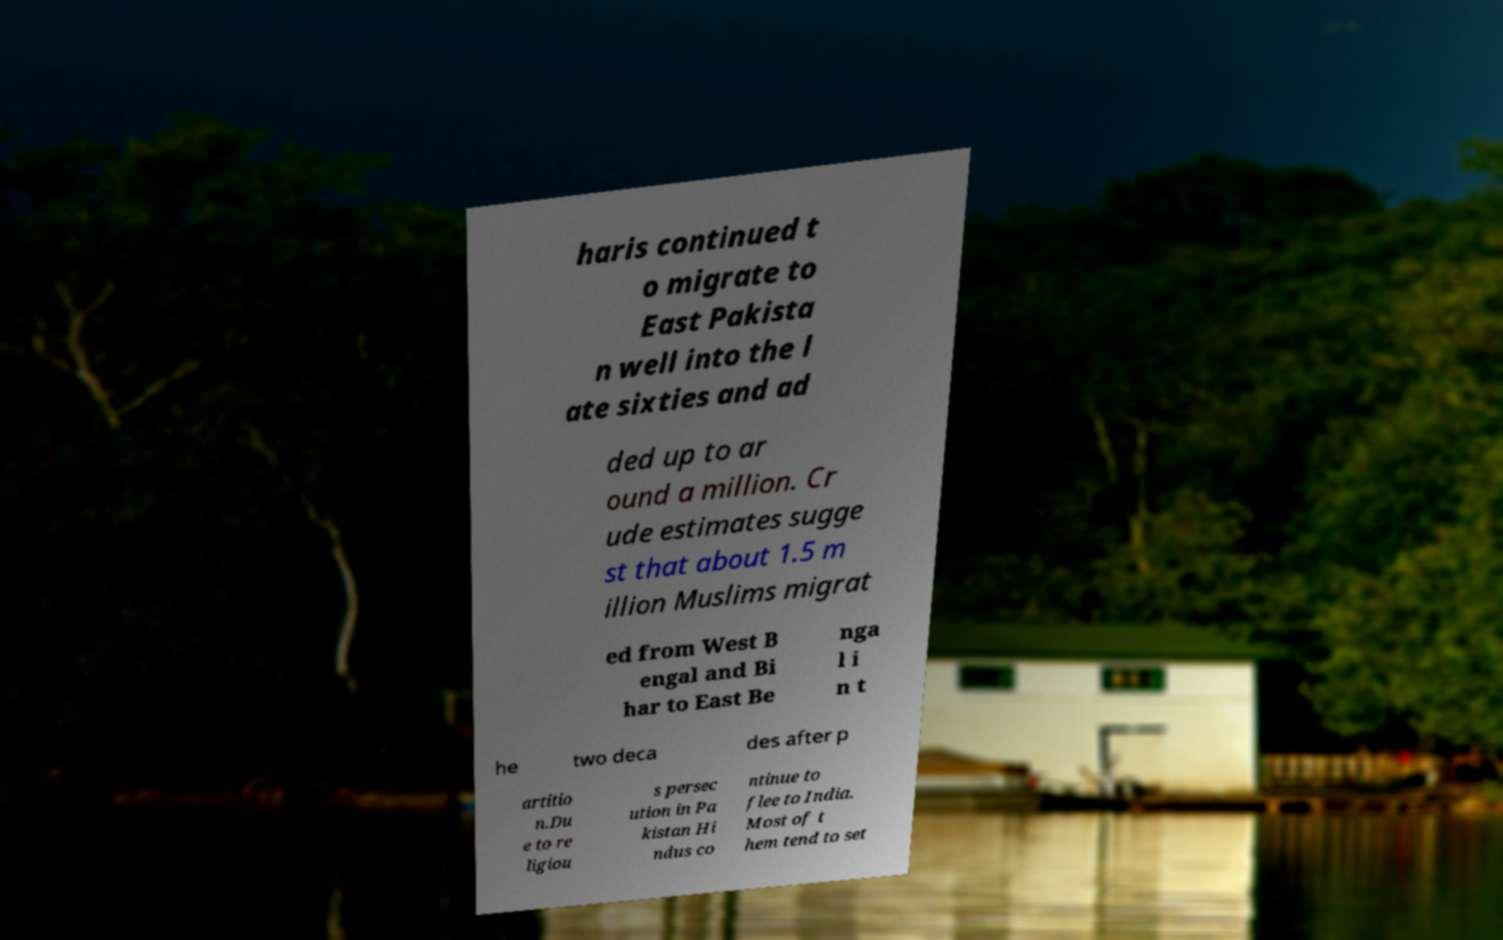There's text embedded in this image that I need extracted. Can you transcribe it verbatim? haris continued t o migrate to East Pakista n well into the l ate sixties and ad ded up to ar ound a million. Cr ude estimates sugge st that about 1.5 m illion Muslims migrat ed from West B engal and Bi har to East Be nga l i n t he two deca des after p artitio n.Du e to re ligiou s persec ution in Pa kistan Hi ndus co ntinue to flee to India. Most of t hem tend to set 